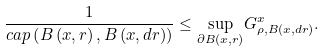<formula> <loc_0><loc_0><loc_500><loc_500>\frac { 1 } { c a p \left ( B \left ( x , r \right ) , B \left ( x , d r \right ) \right ) } \leq \underset { \partial B \left ( x , r \right ) } { \sup } G _ { \rho , B \left ( x , d r \right ) } ^ { x } .</formula> 